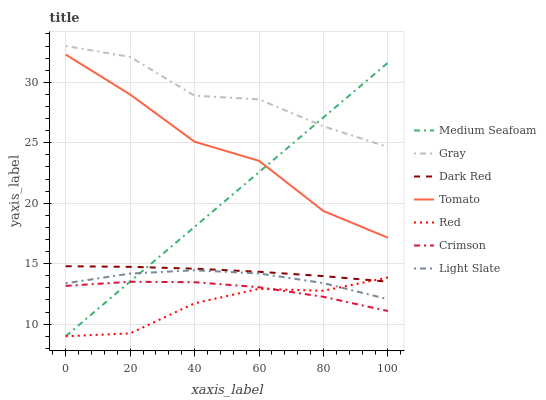Does Red have the minimum area under the curve?
Answer yes or no. Yes. Does Gray have the maximum area under the curve?
Answer yes or no. Yes. Does Light Slate have the minimum area under the curve?
Answer yes or no. No. Does Light Slate have the maximum area under the curve?
Answer yes or no. No. Is Medium Seafoam the smoothest?
Answer yes or no. Yes. Is Gray the roughest?
Answer yes or no. Yes. Is Light Slate the smoothest?
Answer yes or no. No. Is Light Slate the roughest?
Answer yes or no. No. Does Medium Seafoam have the lowest value?
Answer yes or no. Yes. Does Light Slate have the lowest value?
Answer yes or no. No. Does Gray have the highest value?
Answer yes or no. Yes. Does Light Slate have the highest value?
Answer yes or no. No. Is Light Slate less than Tomato?
Answer yes or no. Yes. Is Gray greater than Light Slate?
Answer yes or no. Yes. Does Red intersect Light Slate?
Answer yes or no. Yes. Is Red less than Light Slate?
Answer yes or no. No. Is Red greater than Light Slate?
Answer yes or no. No. Does Light Slate intersect Tomato?
Answer yes or no. No. 